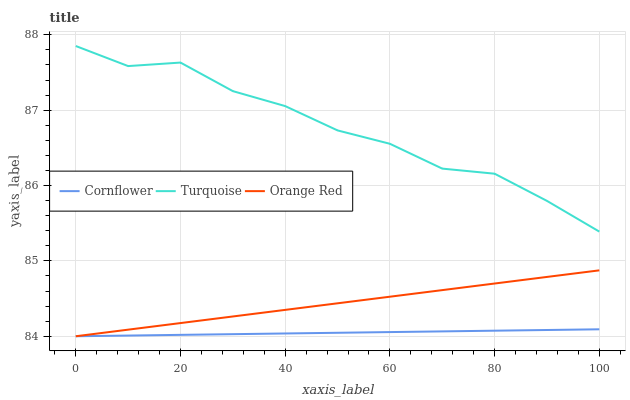Does Cornflower have the minimum area under the curve?
Answer yes or no. Yes. Does Turquoise have the maximum area under the curve?
Answer yes or no. Yes. Does Orange Red have the minimum area under the curve?
Answer yes or no. No. Does Orange Red have the maximum area under the curve?
Answer yes or no. No. Is Orange Red the smoothest?
Answer yes or no. Yes. Is Turquoise the roughest?
Answer yes or no. Yes. Is Turquoise the smoothest?
Answer yes or no. No. Is Orange Red the roughest?
Answer yes or no. No. Does Cornflower have the lowest value?
Answer yes or no. Yes. Does Turquoise have the lowest value?
Answer yes or no. No. Does Turquoise have the highest value?
Answer yes or no. Yes. Does Orange Red have the highest value?
Answer yes or no. No. Is Cornflower less than Turquoise?
Answer yes or no. Yes. Is Turquoise greater than Orange Red?
Answer yes or no. Yes. Does Orange Red intersect Cornflower?
Answer yes or no. Yes. Is Orange Red less than Cornflower?
Answer yes or no. No. Is Orange Red greater than Cornflower?
Answer yes or no. No. Does Cornflower intersect Turquoise?
Answer yes or no. No. 